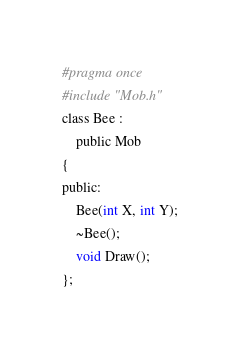Convert code to text. <code><loc_0><loc_0><loc_500><loc_500><_C_>#pragma once
#include "Mob.h"
class Bee :
	public Mob
{
public:
	Bee(int X, int Y);
	~Bee();
	void Draw();
};

</code> 